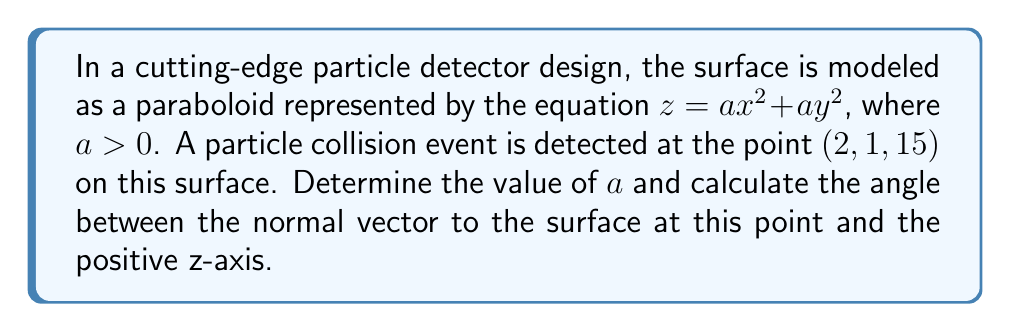Can you answer this question? Let's approach this step-by-step:

1) First, we need to find the value of $a$. We know that the point $(2, 1, 15)$ lies on the surface, so it must satisfy the equation:

   $15 = a(2^2) + a(1^2)$
   $15 = 4a + a = 5a$
   $a = 3$

2) Now that we have $a$, the equation of the paraboloid is $z = 3x^2 + 3y^2$

3) To find the normal vector, we need to calculate the gradient of the surface at the point $(2, 1, 15)$:

   $\nabla f = (6x, 6y, -1)$

   At the point $(2, 1, 15)$, the normal vector is:
   $\vec{n} = (12, 6, -1)$

4) The positive z-axis direction is given by the vector $\vec{v} = (0, 0, 1)$

5) To find the angle between these vectors, we use the dot product formula:

   $\cos \theta = \frac{\vec{n} \cdot \vec{v}}{|\vec{n}||\vec{v}|}$

6) Calculate $|\vec{n}|$:
   $|\vec{n}| = \sqrt{12^2 + 6^2 + (-1)^2} = \sqrt{185}$

7) Now, let's calculate the dot product:
   $\vec{n} \cdot \vec{v} = 12(0) + 6(0) + (-1)(1) = -1$

8) Substituting into the formula:

   $\cos \theta = \frac{-1}{\sqrt{185} \cdot 1} = -\frac{1}{\sqrt{185}}$

9) Taking the inverse cosine:

   $\theta = \arccos(-\frac{1}{\sqrt{185}})$
Answer: $a = 3$, $\theta = \arccos(-\frac{1}{\sqrt{185}})$ radians 